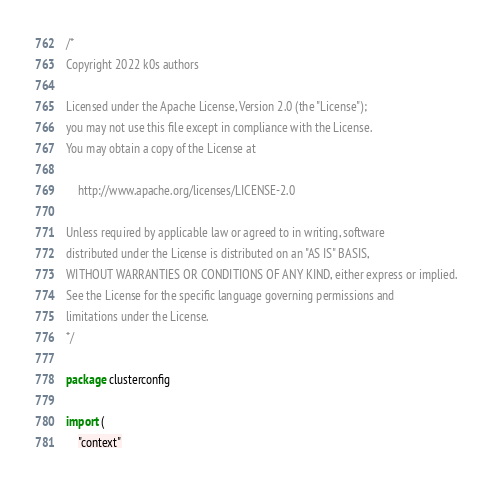<code> <loc_0><loc_0><loc_500><loc_500><_Go_>/*
Copyright 2022 k0s authors

Licensed under the Apache License, Version 2.0 (the "License");
you may not use this file except in compliance with the License.
You may obtain a copy of the License at

    http://www.apache.org/licenses/LICENSE-2.0

Unless required by applicable law or agreed to in writing, software
distributed under the License is distributed on an "AS IS" BASIS,
WITHOUT WARRANTIES OR CONDITIONS OF ANY KIND, either express or implied.
See the License for the specific language governing permissions and
limitations under the License.
*/

package clusterconfig

import (
	"context"
</code> 